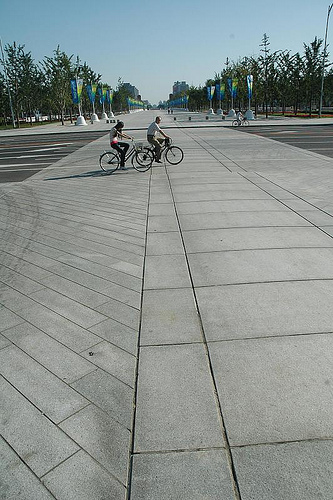<image>
Is there a bicycle to the left of the platform? No. The bicycle is not to the left of the platform. From this viewpoint, they have a different horizontal relationship. 